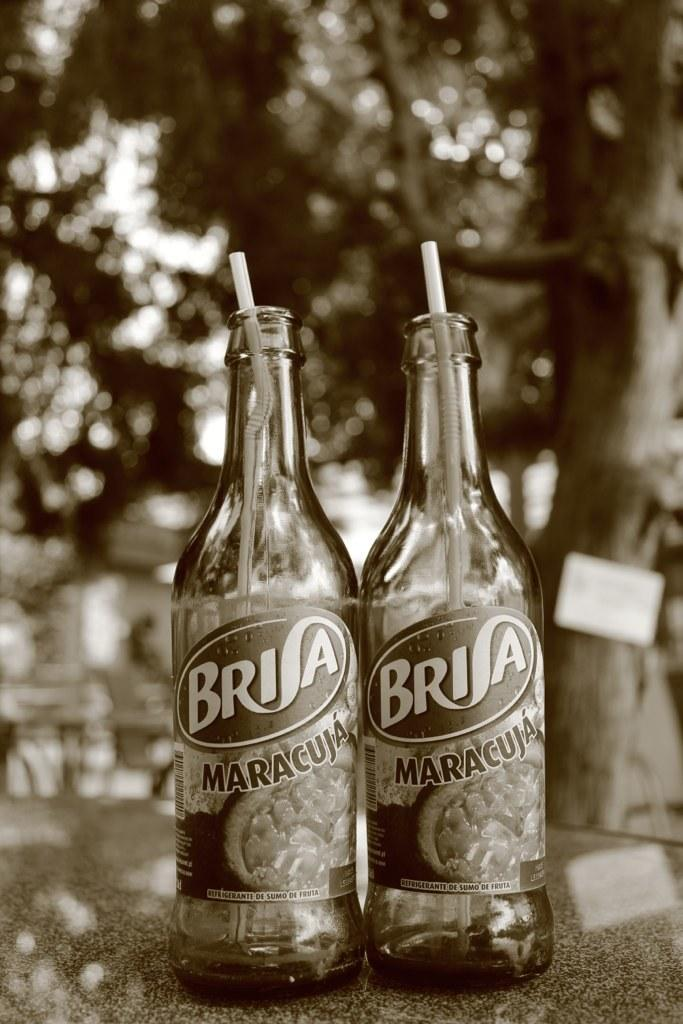<image>
Summarize the visual content of the image. two bottles of brisa maracuja next to one another 